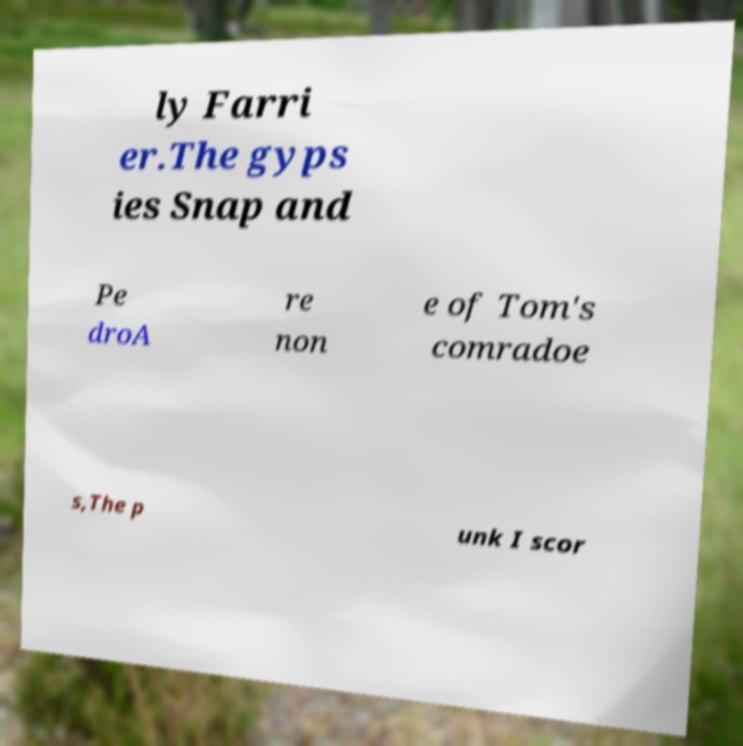Can you accurately transcribe the text from the provided image for me? ly Farri er.The gyps ies Snap and Pe droA re non e of Tom's comradoe s,The p unk I scor 